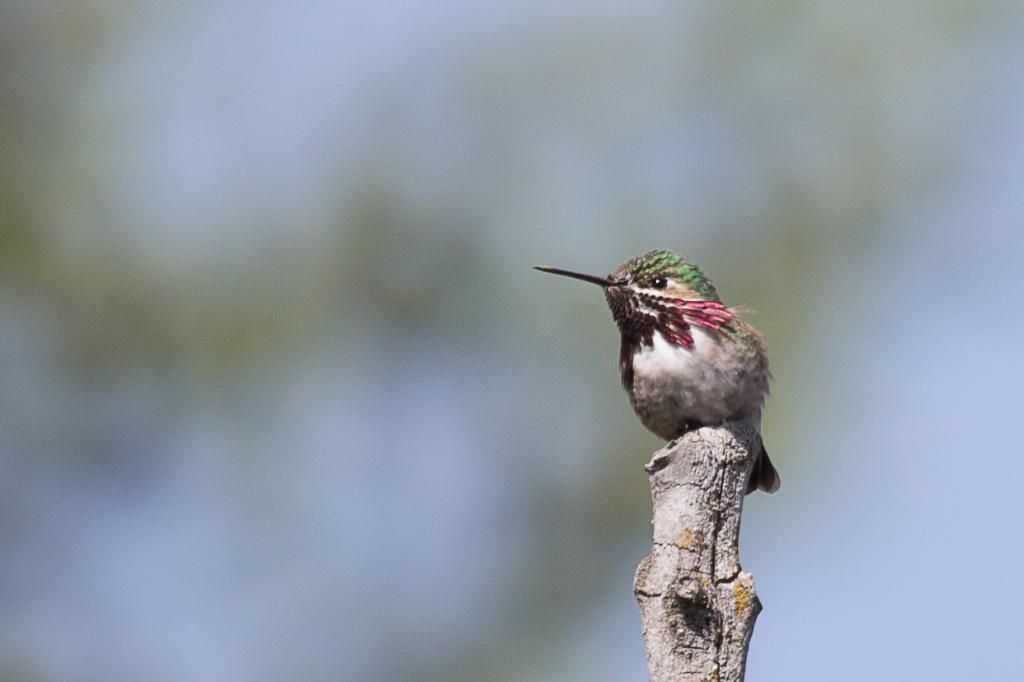Can you describe this image briefly? In this picture there is a bird on the wood. In the back I can see blur image. 